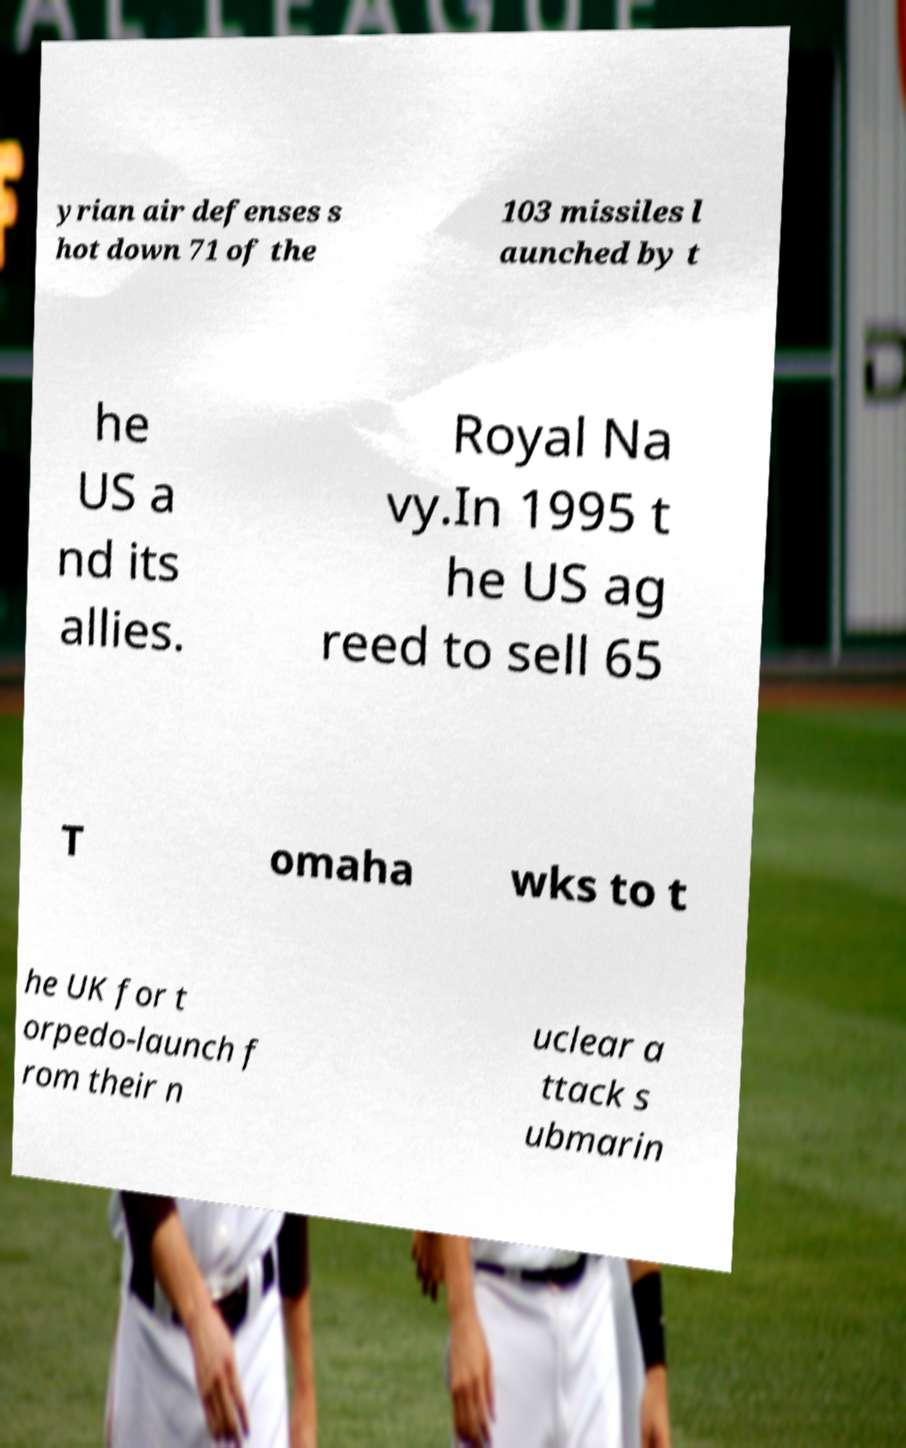I need the written content from this picture converted into text. Can you do that? yrian air defenses s hot down 71 of the 103 missiles l aunched by t he US a nd its allies. Royal Na vy.In 1995 t he US ag reed to sell 65 T omaha wks to t he UK for t orpedo-launch f rom their n uclear a ttack s ubmarin 